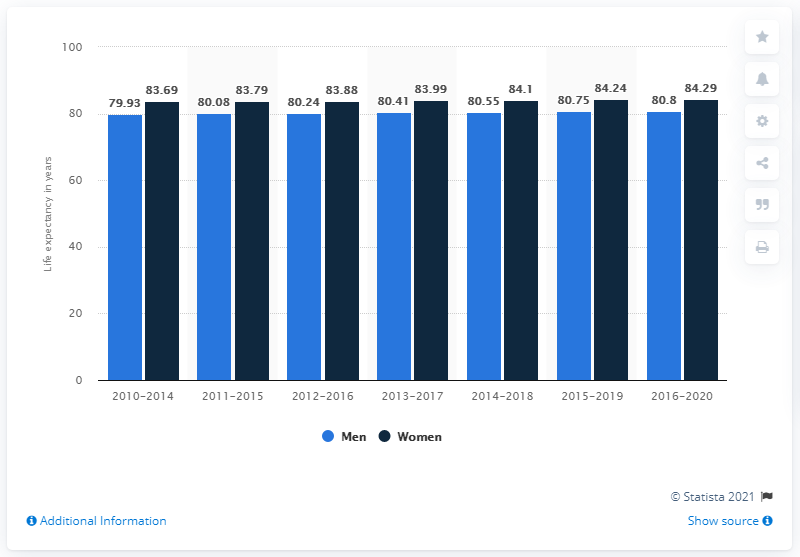Specify some key components in this picture. During the period of 2016 to 2019, the life expectancy of women in Sweden was 84.29 years. 